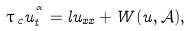Convert formula to latex. <formula><loc_0><loc_0><loc_500><loc_500>\tau \, _ { c } u _ { t } ^ { ^ { \alpha } } = l u _ { x x } + W ( u , \mathcal { A } ) ,</formula> 